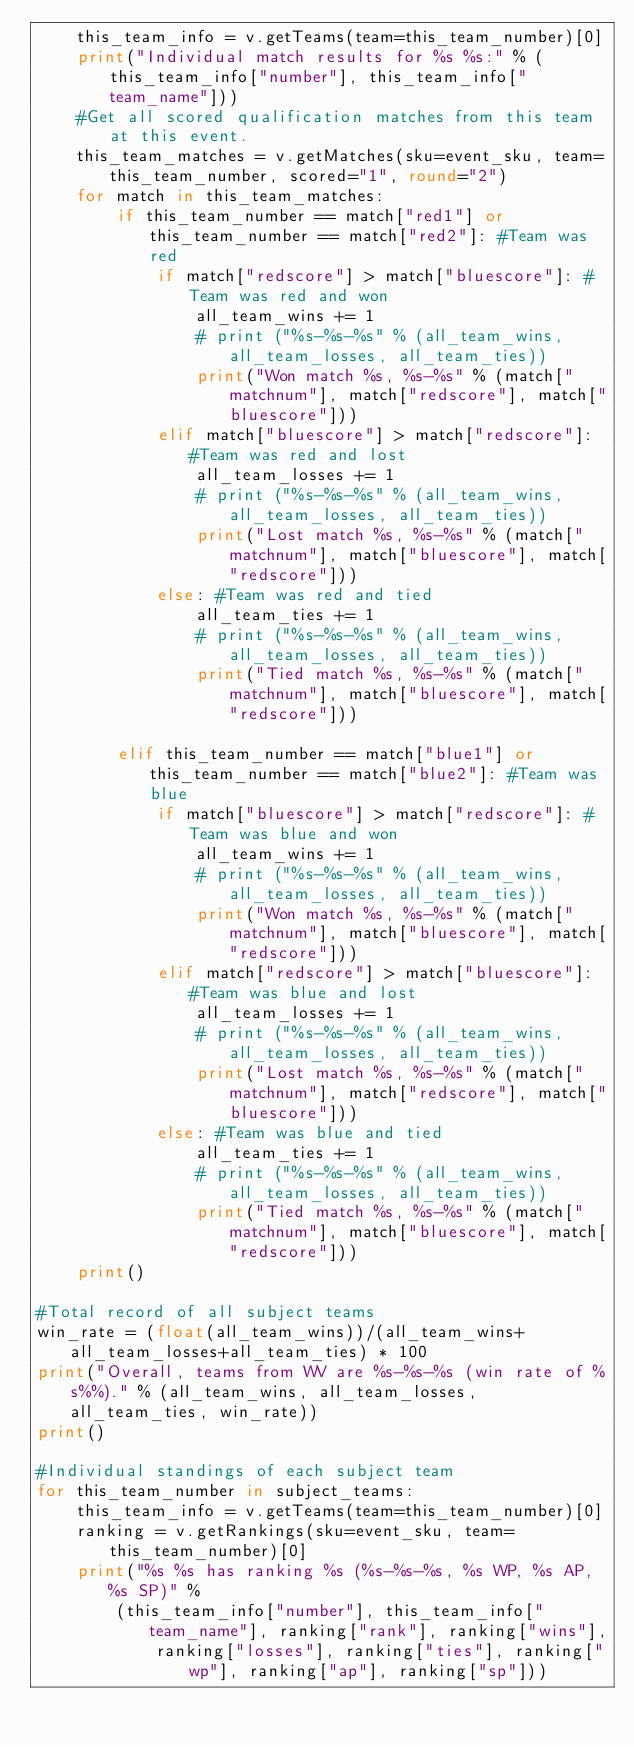Convert code to text. <code><loc_0><loc_0><loc_500><loc_500><_Python_>	this_team_info = v.getTeams(team=this_team_number)[0]
	print("Individual match results for %s %s:" % (this_team_info["number"], this_team_info["team_name"]))
	#Get all scored qualification matches from this team at this event.
	this_team_matches = v.getMatches(sku=event_sku, team=this_team_number, scored="1", round="2")
	for match in this_team_matches:
		if this_team_number == match["red1"] or this_team_number == match["red2"]: #Team was red
			if match["redscore"] > match["bluescore"]: #Team was red and won
				all_team_wins += 1
				# print ("%s-%s-%s" % (all_team_wins, all_team_losses, all_team_ties))
				print("Won match %s, %s-%s" % (match["matchnum"], match["redscore"], match["bluescore"]))
			elif match["bluescore"] > match["redscore"]: #Team was red and lost
				all_team_losses += 1
				# print ("%s-%s-%s" % (all_team_wins, all_team_losses, all_team_ties))
				print("Lost match %s, %s-%s" % (match["matchnum"], match["bluescore"], match["redscore"]))
			else: #Team was red and tied
				all_team_ties += 1
				# print ("%s-%s-%s" % (all_team_wins, all_team_losses, all_team_ties))
				print("Tied match %s, %s-%s" % (match["matchnum"], match["bluescore"], match["redscore"]))

		elif this_team_number == match["blue1"] or this_team_number == match["blue2"]: #Team was blue
			if match["bluescore"] > match["redscore"]: #Team was blue and won
				all_team_wins += 1
				# print ("%s-%s-%s" % (all_team_wins, all_team_losses, all_team_ties))
				print("Won match %s, %s-%s" % (match["matchnum"], match["bluescore"], match["redscore"]))
			elif match["redscore"] > match["bluescore"]: #Team was blue and lost
				all_team_losses += 1
				# print ("%s-%s-%s" % (all_team_wins, all_team_losses, all_team_ties))
				print("Lost match %s, %s-%s" % (match["matchnum"], match["redscore"], match["bluescore"]))
			else: #Team was blue and tied
				all_team_ties += 1
				# print ("%s-%s-%s" % (all_team_wins, all_team_losses, all_team_ties))
				print("Tied match %s, %s-%s" % (match["matchnum"], match["bluescore"], match["redscore"]))
	print()

#Total record of all subject teams
win_rate = (float(all_team_wins))/(all_team_wins+all_team_losses+all_team_ties) * 100
print("Overall, teams from WV are %s-%s-%s (win rate of %s%%)." % (all_team_wins, all_team_losses, all_team_ties, win_rate))
print()

#Individual standings of each subject team
for this_team_number in subject_teams:
	this_team_info = v.getTeams(team=this_team_number)[0]
	ranking = v.getRankings(sku=event_sku, team=this_team_number)[0]
	print("%s %s has ranking %s (%s-%s-%s, %s WP, %s AP, %s SP)" %
		(this_team_info["number"], this_team_info["team_name"], ranking["rank"], ranking["wins"], 
			ranking["losses"], ranking["ties"], ranking["wp"], ranking["ap"], ranking["sp"]))














</code> 